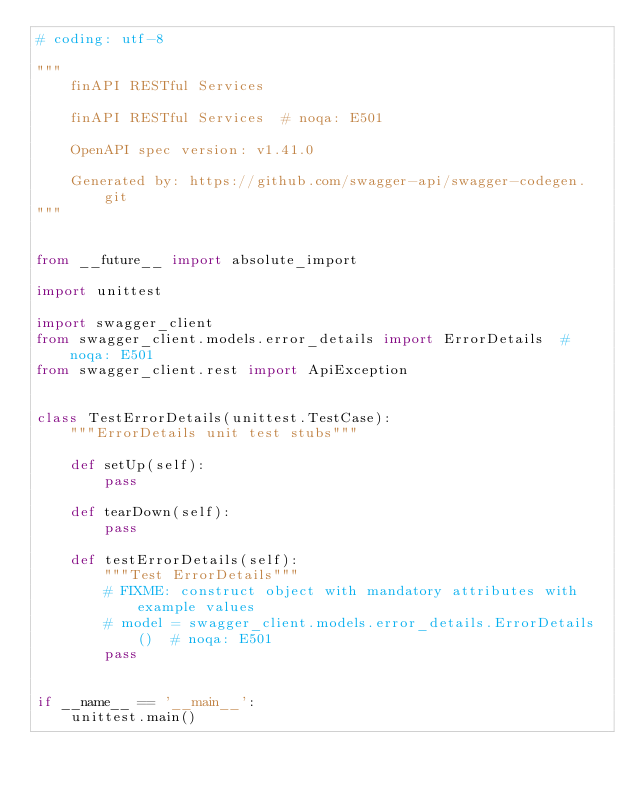Convert code to text. <code><loc_0><loc_0><loc_500><loc_500><_Python_># coding: utf-8

"""
    finAPI RESTful Services

    finAPI RESTful Services  # noqa: E501

    OpenAPI spec version: v1.41.0
    
    Generated by: https://github.com/swagger-api/swagger-codegen.git
"""


from __future__ import absolute_import

import unittest

import swagger_client
from swagger_client.models.error_details import ErrorDetails  # noqa: E501
from swagger_client.rest import ApiException


class TestErrorDetails(unittest.TestCase):
    """ErrorDetails unit test stubs"""

    def setUp(self):
        pass

    def tearDown(self):
        pass

    def testErrorDetails(self):
        """Test ErrorDetails"""
        # FIXME: construct object with mandatory attributes with example values
        # model = swagger_client.models.error_details.ErrorDetails()  # noqa: E501
        pass


if __name__ == '__main__':
    unittest.main()
</code> 